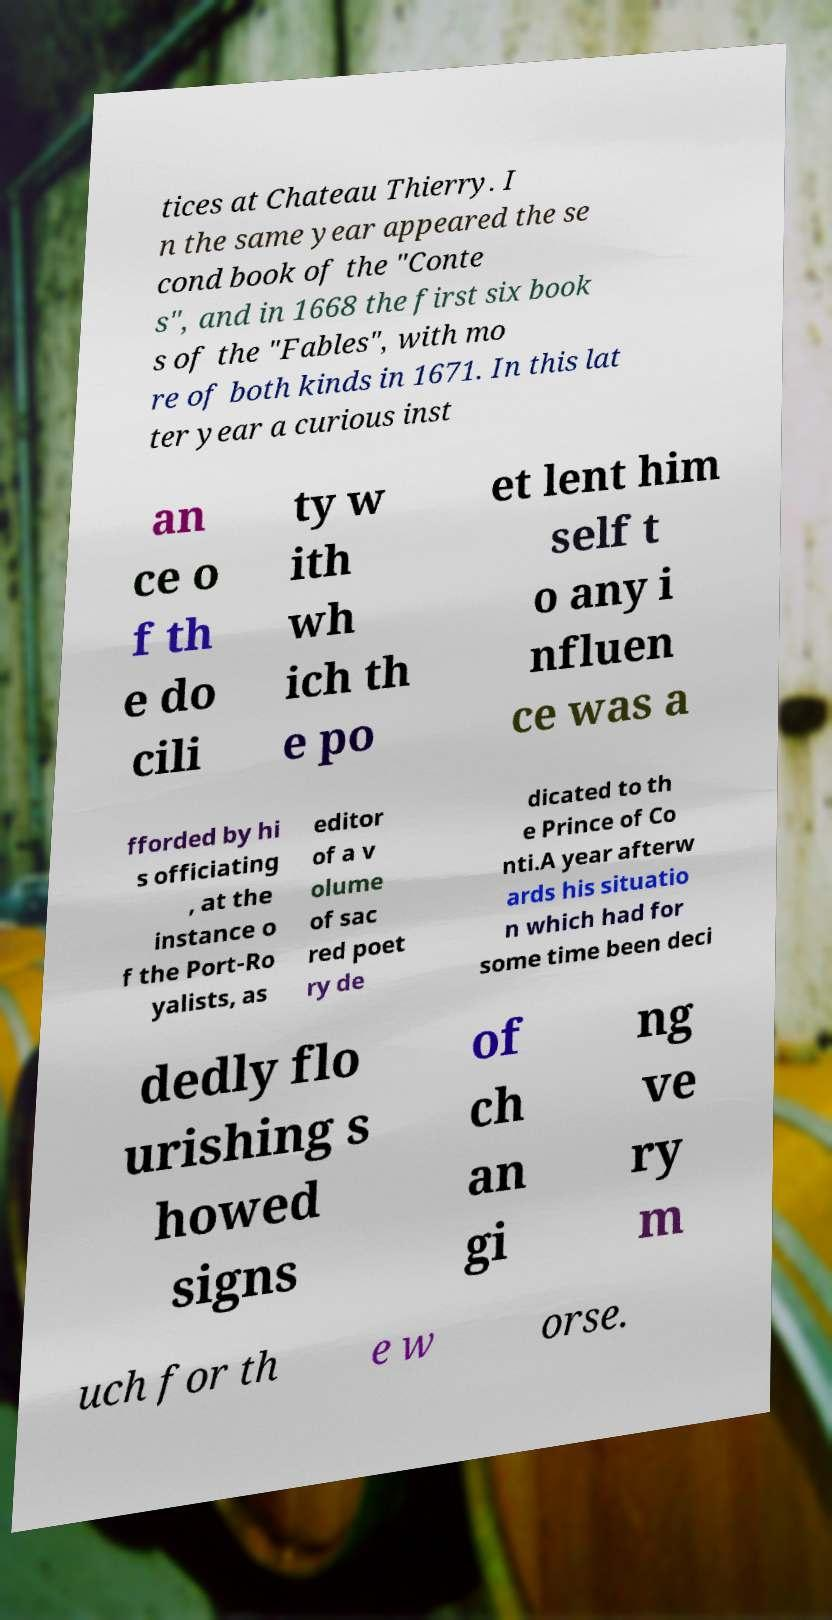Can you read and provide the text displayed in the image?This photo seems to have some interesting text. Can you extract and type it out for me? tices at Chateau Thierry. I n the same year appeared the se cond book of the "Conte s", and in 1668 the first six book s of the "Fables", with mo re of both kinds in 1671. In this lat ter year a curious inst an ce o f th e do cili ty w ith wh ich th e po et lent him self t o any i nfluen ce was a fforded by hi s officiating , at the instance o f the Port-Ro yalists, as editor of a v olume of sac red poet ry de dicated to th e Prince of Co nti.A year afterw ards his situatio n which had for some time been deci dedly flo urishing s howed signs of ch an gi ng ve ry m uch for th e w orse. 